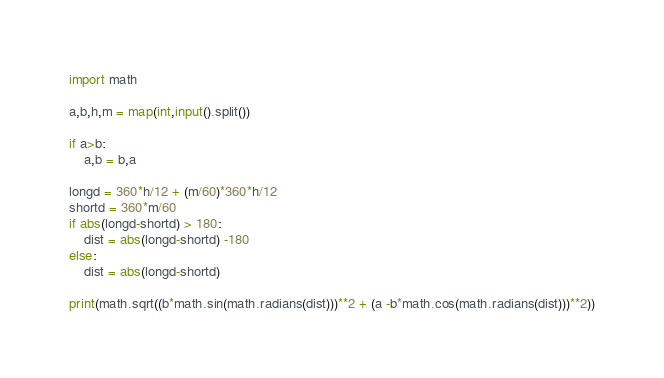Convert code to text. <code><loc_0><loc_0><loc_500><loc_500><_Python_>import math

a,b,h,m = map(int,input().split())

if a>b:
    a,b = b,a

longd = 360*h/12 + (m/60)*360*h/12
shortd = 360*m/60
if abs(longd-shortd) > 180:
    dist = abs(longd-shortd) -180
else:
    dist = abs(longd-shortd)

print(math.sqrt((b*math.sin(math.radians(dist)))**2 + (a -b*math.cos(math.radians(dist)))**2))
</code> 